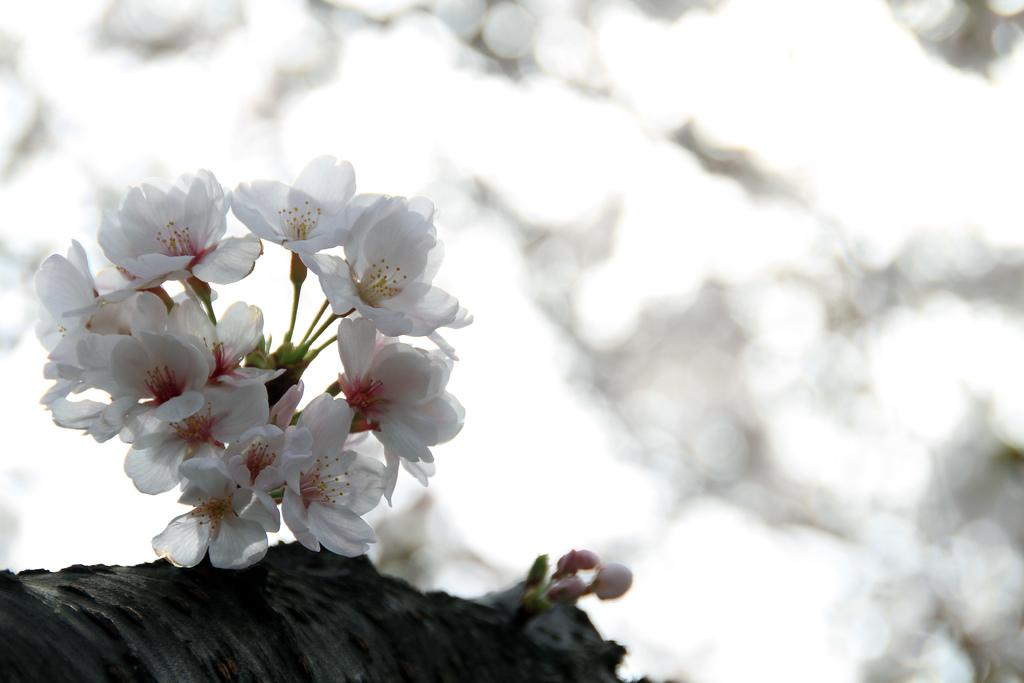What type of flowers are in the foreground of the image? There are white flowers in the foreground of the image. How are the flowers arranged in the image? The flowers are on a stem. What can be observed about the background of the image? The background of the image is blurred. What type of birthday celebration is happening in the image? There is no indication of a birthday celebration in the image; it features white flowers on a stem with a blurred background. 